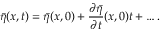<formula> <loc_0><loc_0><loc_500><loc_500>\bar { \eta } ( x , t ) = \bar { \eta } ( x , 0 ) + \frac { \partial \bar { \eta } } { \partial t } ( x , 0 ) t + \dots .</formula> 